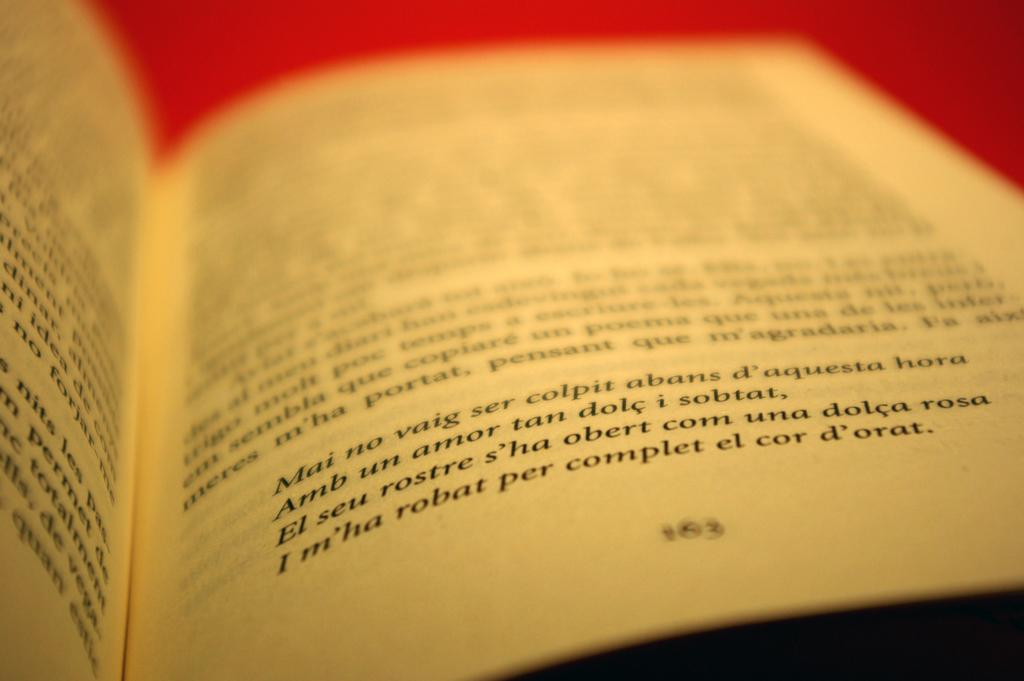Provide a one-sentence caption for the provided image. An open book shows a page with a passage in French that ends with the word "d'orat.". 